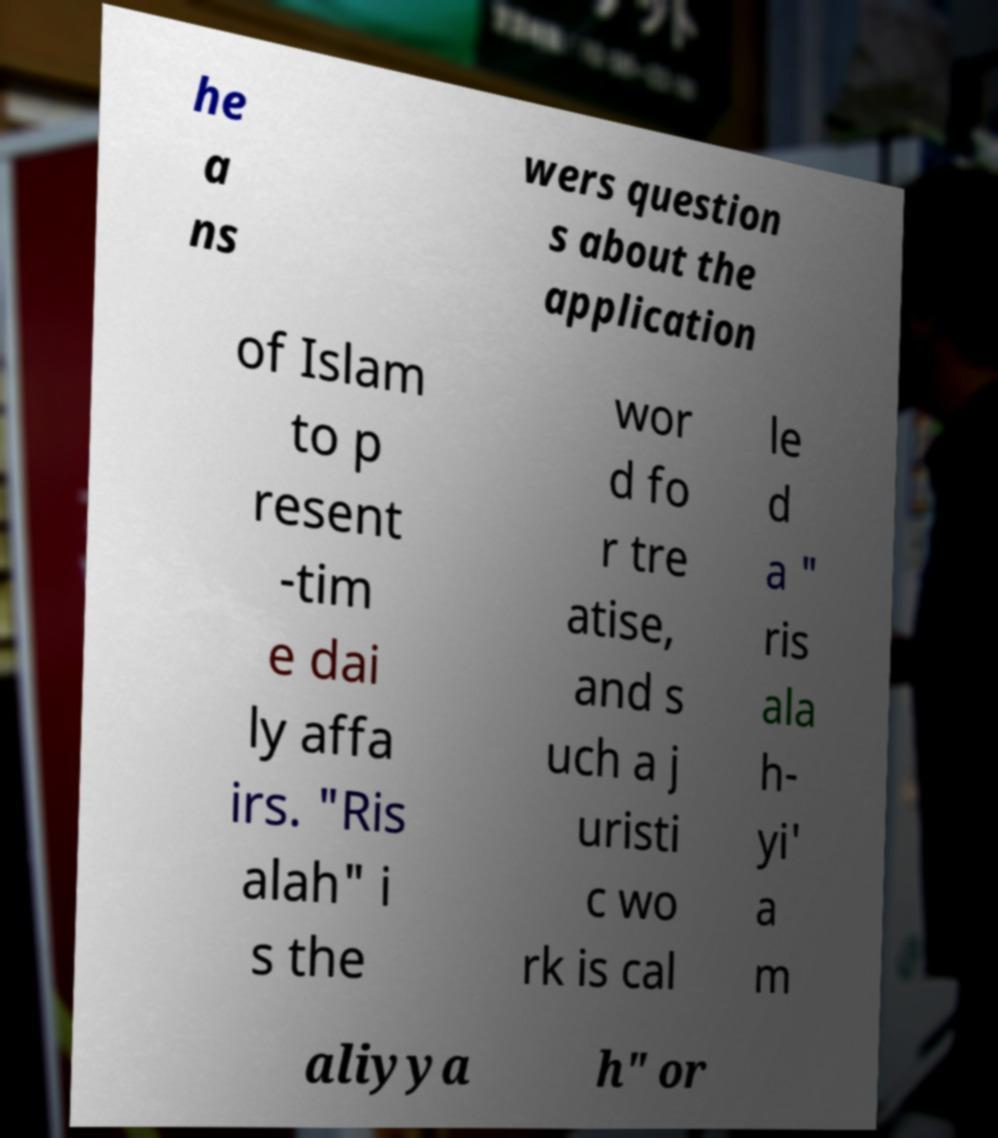There's text embedded in this image that I need extracted. Can you transcribe it verbatim? he a ns wers question s about the application of Islam to p resent -tim e dai ly affa irs. "Ris alah" i s the wor d fo r tre atise, and s uch a j uristi c wo rk is cal le d a " ris ala h- yi' a m aliyya h" or 